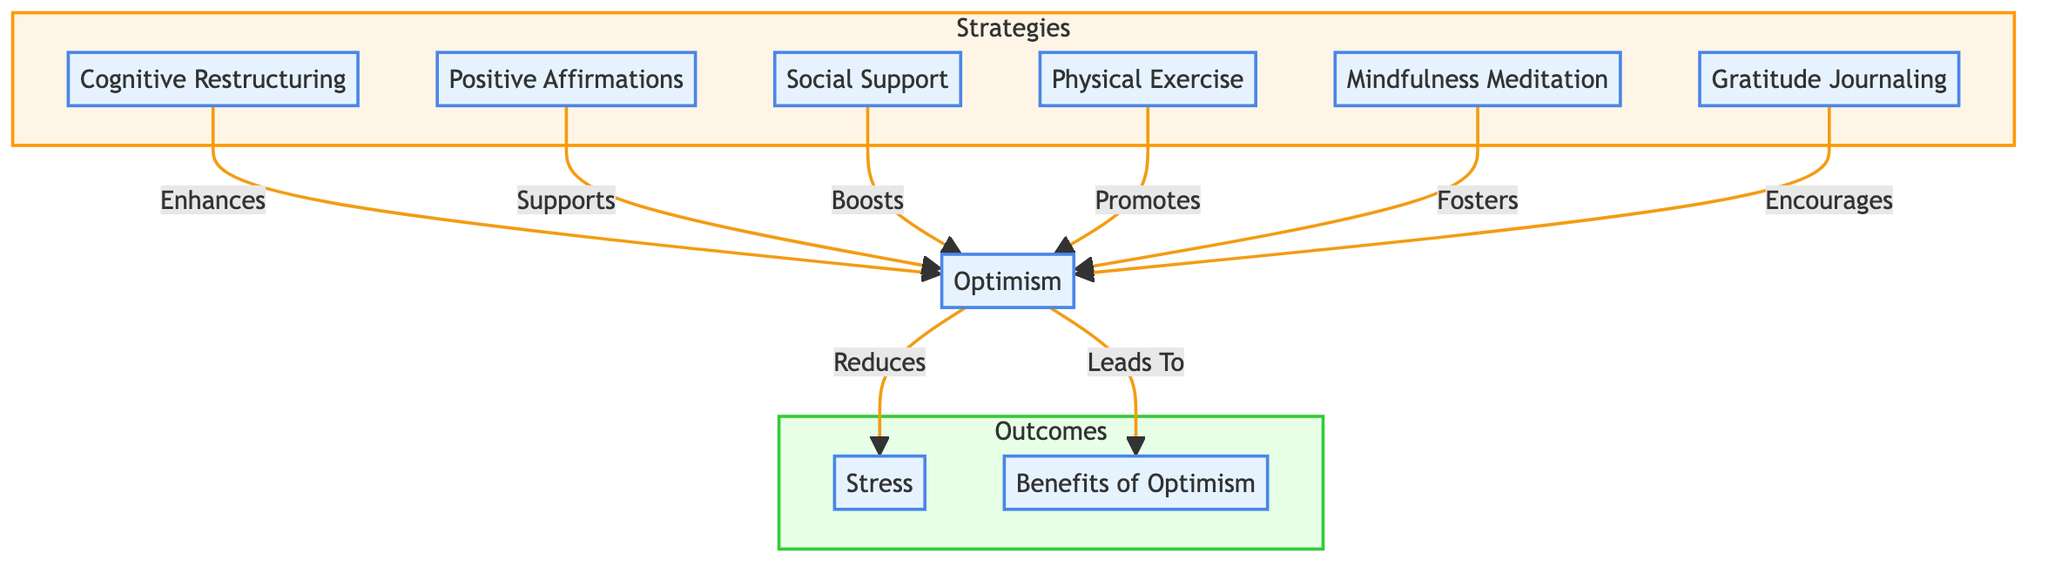What is the first block in the diagram? The first block listed is "Optimism," which is the starting point of the flow and represents the positive mental attitude.
Answer: Optimism How many strategies are outlined in the diagram? There are six strategies listed within the "Strategies" subgraph, namely Cognitive Restructuring, Positive Affirmations, Social Support, Physical Exercise, Mindfulness Meditation, and Gratitude Journaling.
Answer: Six What does Stress connect to in the diagram? Stress connects to the block “Optimism,” indicating that optimism influences stress levels by reducing perceived stress.
Answer: Optimism What type of connection is made from Cognitive Restructuring to Optimism? The connection type is "Enhances," indicating that Cognitive Restructuring positively impacts the development of an optimistic outlook.
Answer: Enhances Which block leads to benefits as per the diagram? The block "Optimism" leads to the block "Benefits of Optimism," suggesting that an optimistic mindset results in various positive outcomes.
Answer: Optimism What color represents the connection types in the diagram? The connections are represented in yellow, which differentiates them from the blocks and indicates the relationships between them.
Answer: Yellow How does Social Support influence Optimism? The connection indicates that Social Support "Boosts" feelings of optimism, emphasizing the positive effects of support systems on optimism.
Answer: Boosts Which strategy is associated with fostering an optimistic outlook? Mindfulness Meditation is specifically mentioned as a practice that fosters an optimistic outlook by reducing negative thinking patterns.
Answer: Mindfulness Meditation How many total blocks are in the diagram? There are ten blocks in total, including all strategies and outcome blocks, as indicated in both the Strategies and Outcomes sections of the diagram.
Answer: Ten 